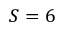Convert formula to latex. <formula><loc_0><loc_0><loc_500><loc_500>S = 6</formula> 